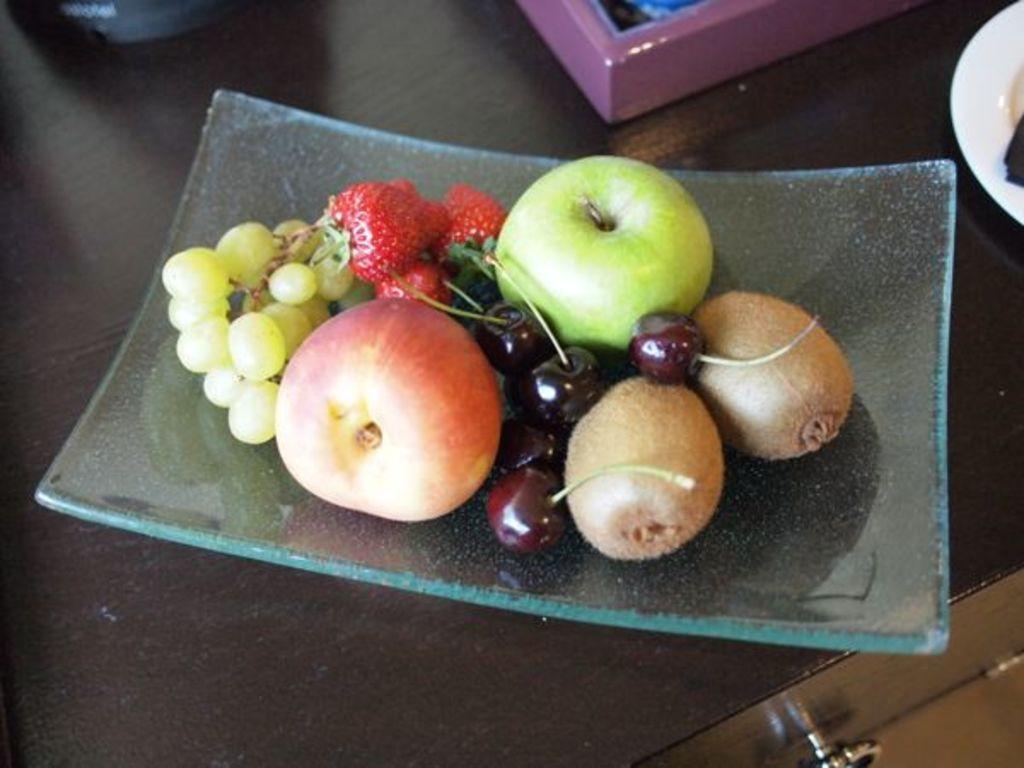In one or two sentences, can you explain what this image depicts? In this image, we can see a table, on the table, we can see a tray with some fruits. On the right side, we can see one edge of a plate. In the background, we can see pink color box. 